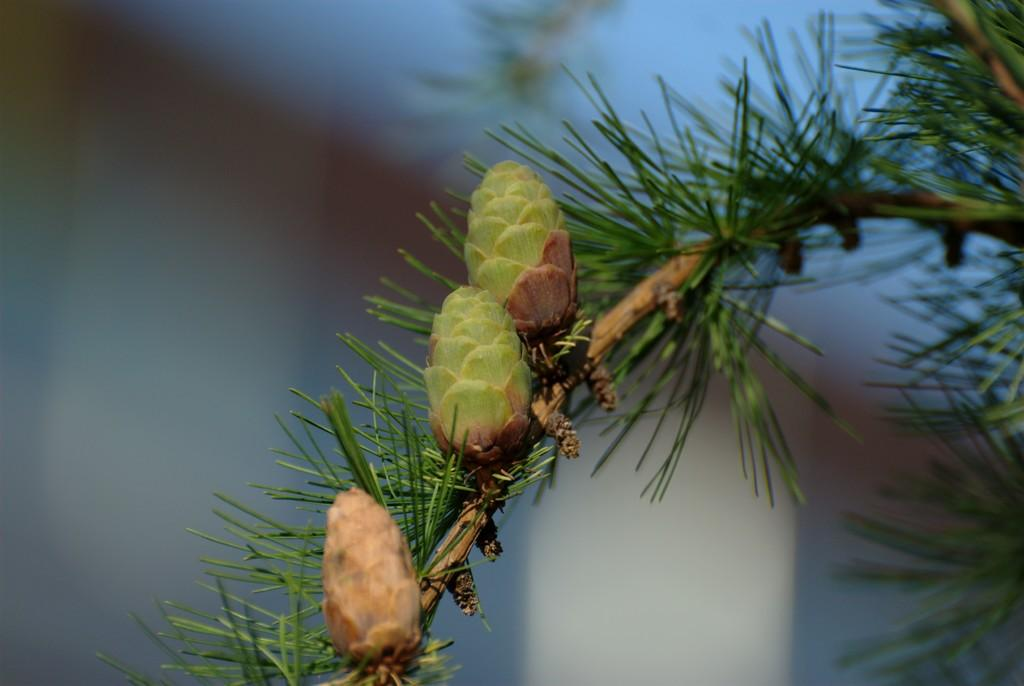What type of fruit is visible in the image? There is a pinus serotina fruit in the image. How is the fruit connected to the plant? The fruit is attached to a stem. What other plant parts can be seen in the image? Leaves are present in the image. Can you describe the background of the image? The background of the image is blurred. How many birds are sitting on the patch in the image? There are no birds or patches present in the image. 